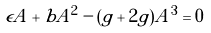<formula> <loc_0><loc_0><loc_500><loc_500>\epsilon A + b A ^ { 2 } - ( g + 2 \tilde { g } ) A ^ { 3 } = 0</formula> 